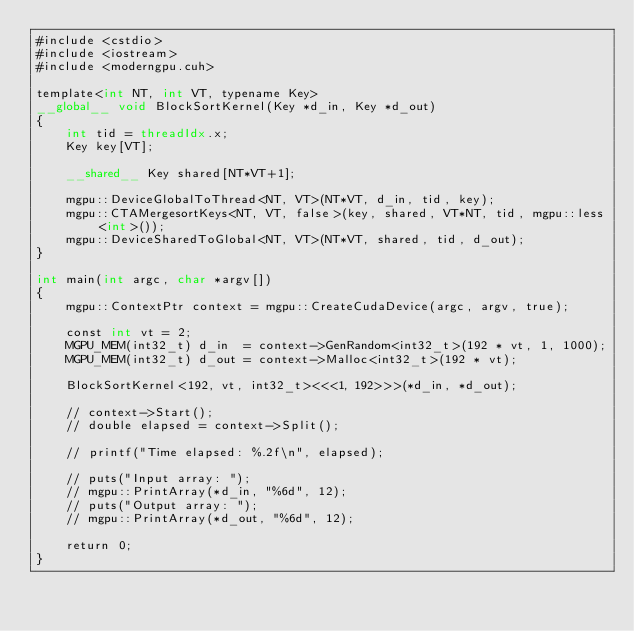<code> <loc_0><loc_0><loc_500><loc_500><_Cuda_>#include <cstdio>
#include <iostream>
#include <moderngpu.cuh>

template<int NT, int VT, typename Key>
__global__ void BlockSortKernel(Key *d_in, Key *d_out)
{
    int tid = threadIdx.x;
    Key key[VT];

    __shared__ Key shared[NT*VT+1];

    mgpu::DeviceGlobalToThread<NT, VT>(NT*VT, d_in, tid, key);
    mgpu::CTAMergesortKeys<NT, VT, false>(key, shared, VT*NT, tid, mgpu::less<int>());
    mgpu::DeviceSharedToGlobal<NT, VT>(NT*VT, shared, tid, d_out);
}

int main(int argc, char *argv[])
{
    mgpu::ContextPtr context = mgpu::CreateCudaDevice(argc, argv, true);

    const int vt = 2;
    MGPU_MEM(int32_t) d_in  = context->GenRandom<int32_t>(192 * vt, 1, 1000);
    MGPU_MEM(int32_t) d_out = context->Malloc<int32_t>(192 * vt);

    BlockSortKernel<192, vt, int32_t><<<1, 192>>>(*d_in, *d_out);

    // context->Start();
    // double elapsed = context->Split();

    // printf("Time elapsed: %.2f\n", elapsed);

    // puts("Input array: ");
    // mgpu::PrintArray(*d_in, "%6d", 12);
    // puts("Output array: ");
    // mgpu::PrintArray(*d_out, "%6d", 12);

    return 0;
}
</code> 